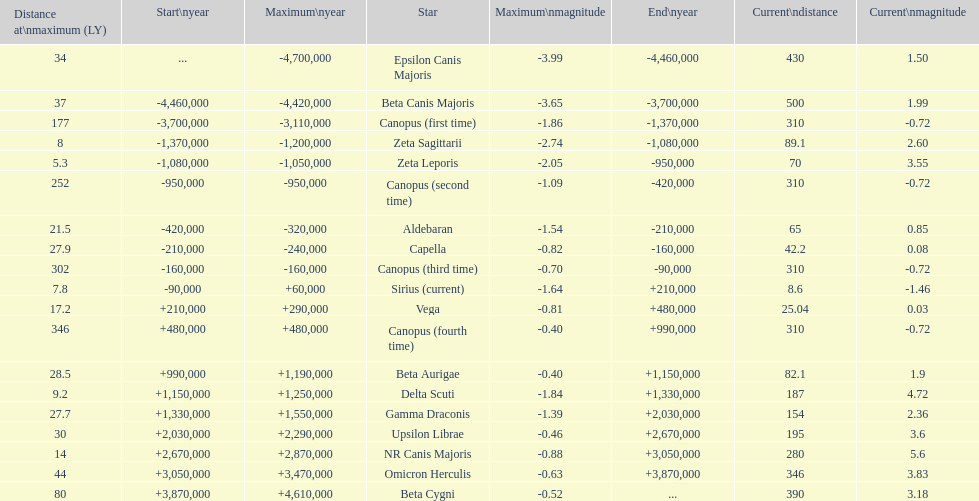How much farther (in ly) is epsilon canis majoris than zeta sagittarii? 26. Write the full table. {'header': ['Distance at\\nmaximum (LY)', 'Start\\nyear', 'Maximum\\nyear', 'Star', 'Maximum\\nmagnitude', 'End\\nyear', 'Current\\ndistance', 'Current\\nmagnitude'], 'rows': [['34', '...', '-4,700,000', 'Epsilon Canis Majoris', '-3.99', '-4,460,000', '430', '1.50'], ['37', '-4,460,000', '-4,420,000', 'Beta Canis Majoris', '-3.65', '-3,700,000', '500', '1.99'], ['177', '-3,700,000', '-3,110,000', 'Canopus (first time)', '-1.86', '-1,370,000', '310', '-0.72'], ['8', '-1,370,000', '-1,200,000', 'Zeta Sagittarii', '-2.74', '-1,080,000', '89.1', '2.60'], ['5.3', '-1,080,000', '-1,050,000', 'Zeta Leporis', '-2.05', '-950,000', '70', '3.55'], ['252', '-950,000', '-950,000', 'Canopus (second time)', '-1.09', '-420,000', '310', '-0.72'], ['21.5', '-420,000', '-320,000', 'Aldebaran', '-1.54', '-210,000', '65', '0.85'], ['27.9', '-210,000', '-240,000', 'Capella', '-0.82', '-160,000', '42.2', '0.08'], ['302', '-160,000', '-160,000', 'Canopus (third time)', '-0.70', '-90,000', '310', '-0.72'], ['7.8', '-90,000', '+60,000', 'Sirius (current)', '-1.64', '+210,000', '8.6', '-1.46'], ['17.2', '+210,000', '+290,000', 'Vega', '-0.81', '+480,000', '25.04', '0.03'], ['346', '+480,000', '+480,000', 'Canopus (fourth time)', '-0.40', '+990,000', '310', '-0.72'], ['28.5', '+990,000', '+1,190,000', 'Beta Aurigae', '-0.40', '+1,150,000', '82.1', '1.9'], ['9.2', '+1,150,000', '+1,250,000', 'Delta Scuti', '-1.84', '+1,330,000', '187', '4.72'], ['27.7', '+1,330,000', '+1,550,000', 'Gamma Draconis', '-1.39', '+2,030,000', '154', '2.36'], ['30', '+2,030,000', '+2,290,000', 'Upsilon Librae', '-0.46', '+2,670,000', '195', '3.6'], ['14', '+2,670,000', '+2,870,000', 'NR Canis Majoris', '-0.88', '+3,050,000', '280', '5.6'], ['44', '+3,050,000', '+3,470,000', 'Omicron Herculis', '-0.63', '+3,870,000', '346', '3.83'], ['80', '+3,870,000', '+4,610,000', 'Beta Cygni', '-0.52', '...', '390', '3.18']]} 